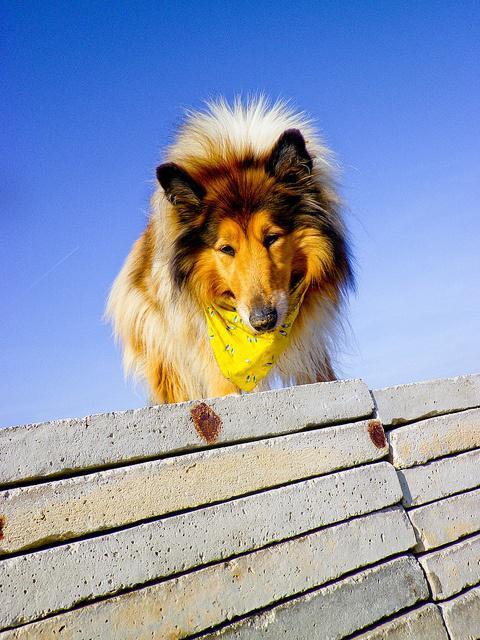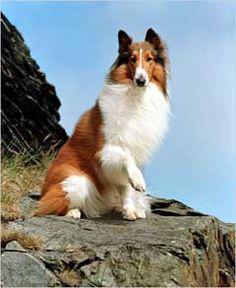The first image is the image on the left, the second image is the image on the right. Considering the images on both sides, is "Exactly one dog is sitting." valid? Answer yes or no. Yes. The first image is the image on the left, the second image is the image on the right. Evaluate the accuracy of this statement regarding the images: "a body of water is visible behind a dog". Is it true? Answer yes or no. No. 